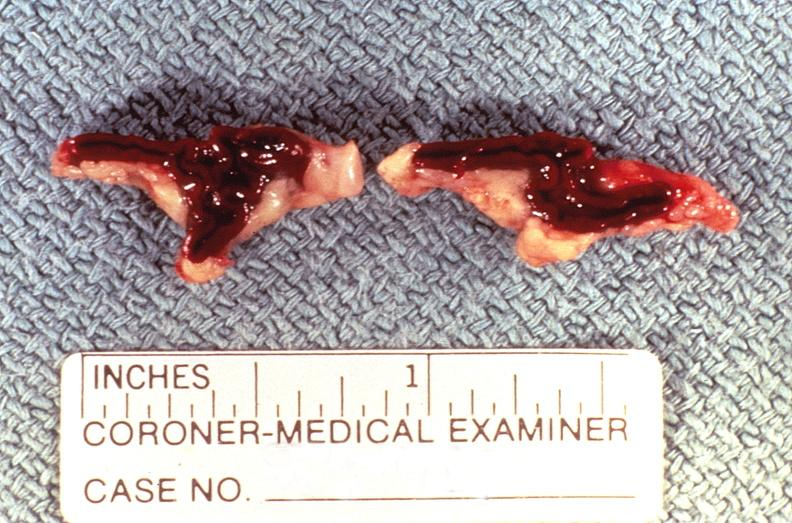s endocrine present?
Answer the question using a single word or phrase. Yes 